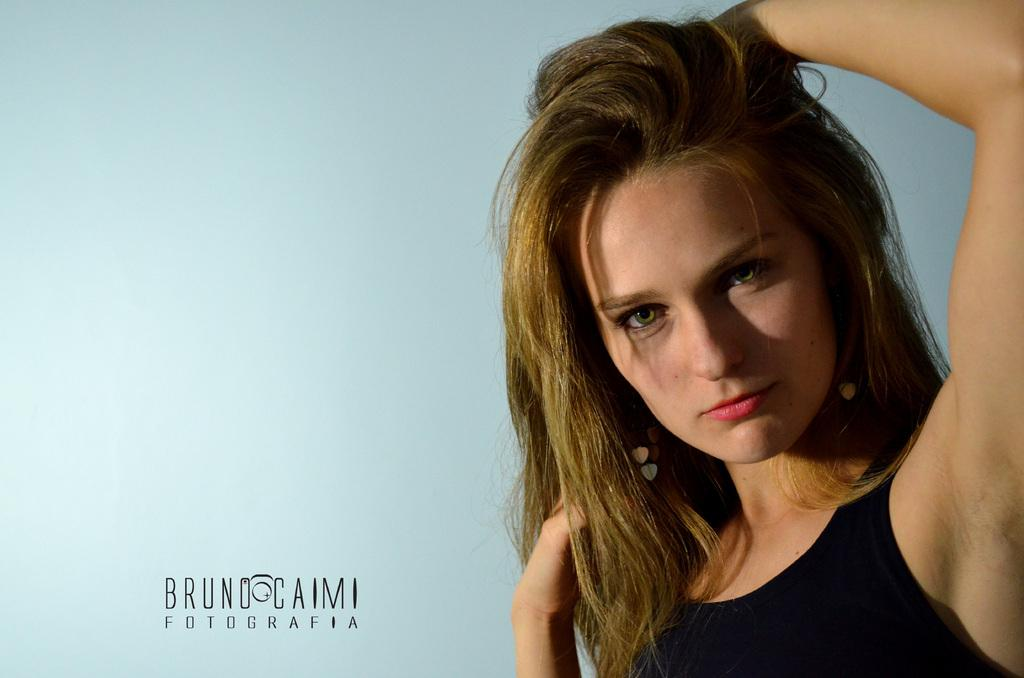What is the main subject of the image? There is a woman in the image. Can you describe any additional features or elements in the image? There is text written on the image. What type of plastic pan is being used by the woman in the image? There is no plastic pan present in the image. Can you describe the bee that is buzzing around the woman in the image? There is no bee present in the image. 